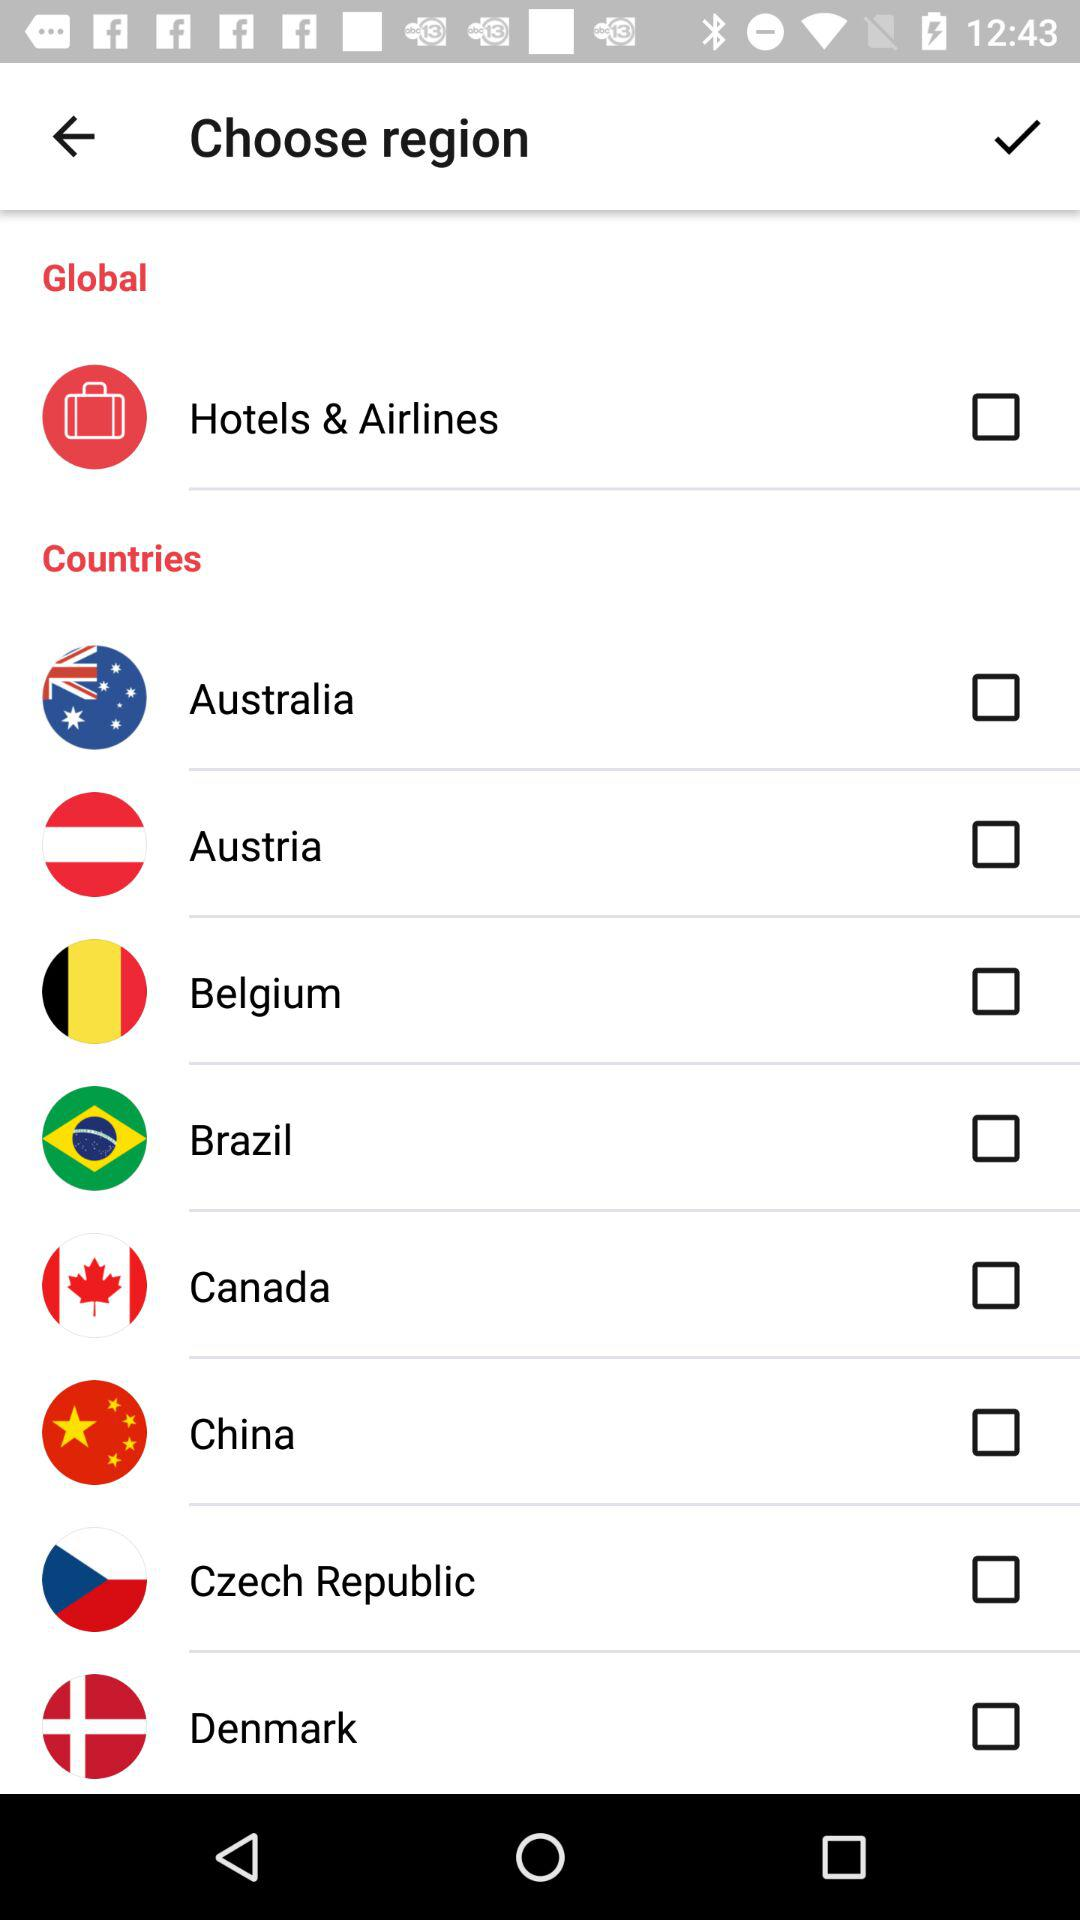What is the status of "Hotels & Airlines"? The status is "off". 